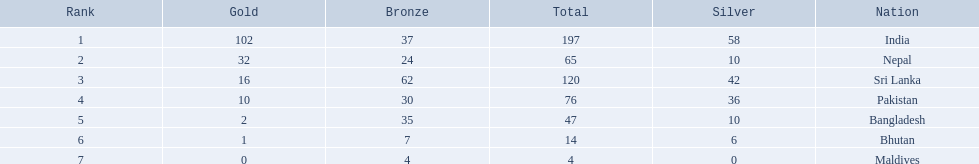Name the first country on the table? India. 